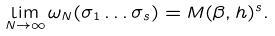<formula> <loc_0><loc_0><loc_500><loc_500>\lim _ { N \to \infty } \omega _ { N } ( \sigma _ { 1 } \dots \sigma _ { s } ) = M ( \beta , h ) ^ { s } .</formula> 